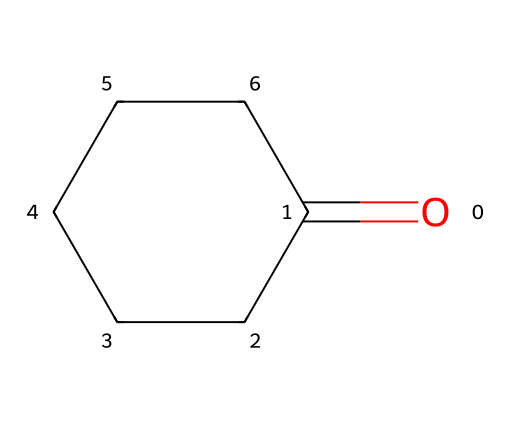What is the molecular formula of cyclohexanone? To find the molecular formula, count the number of carbon (C), hydrogen (H), and oxygen (O) atoms in the structure: there are 6 carbons, 10 hydrogens, and 1 oxygen. Thus, the molecular formula is C6H10O.
Answer: C6H10O How many carbon atoms are in cyclohexanone? We can determine the number of carbon atoms by looking at the cyclohexane ring structure where each vertex represents a carbon atom. There are 6 vertices, thus there are 6 carbon atoms.
Answer: 6 What type of functional group is present in cyclohexanone? The structure contains a carbonyl group (C=O), which is characteristic of ketones. This functional group indicates that cyclohexanone is a ketone.
Answer: ketone How many hydrogen atoms are bonded to the carbonyl carbon? The carbonyl carbon in a ketone typically has no hydrogen directly attached to it. In this structure, the carbonyl group shows that the carbon is double-bonded to oxygen and only bonded to the rest of the carbon chain.
Answer: 0 What is the melting point of cyclohexanone? Cyclohexanone has a melting point of around -31.5 degrees Celsius, which is common data associated with this specific ketone.
Answer: -31.5 degrees Celsius Is cyclohexanone polar or nonpolar? Considering the presence of the carbonyl group (C=O), cyclohexanone has polar characteristics due to this electronegative oxygen pulling electron density away from the carbon atoms. Therefore, the molecule is polar.
Answer: polar 